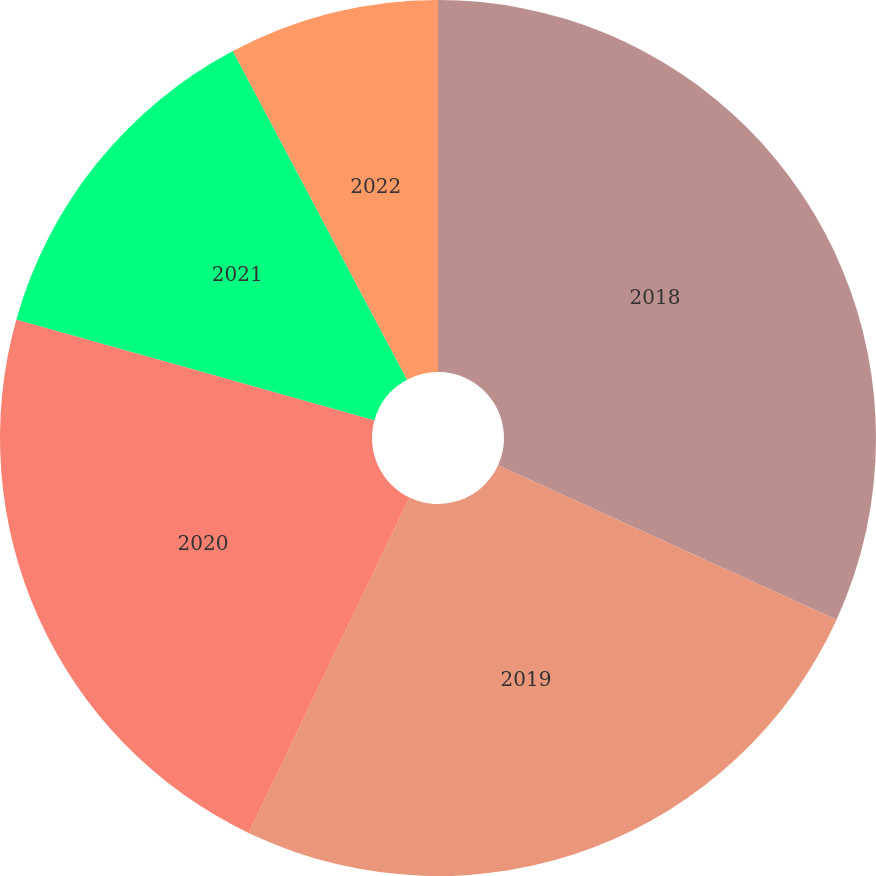<chart> <loc_0><loc_0><loc_500><loc_500><pie_chart><fcel>2018<fcel>2019<fcel>2020<fcel>2021<fcel>2022<nl><fcel>31.81%<fcel>25.31%<fcel>22.25%<fcel>12.88%<fcel>7.76%<nl></chart> 